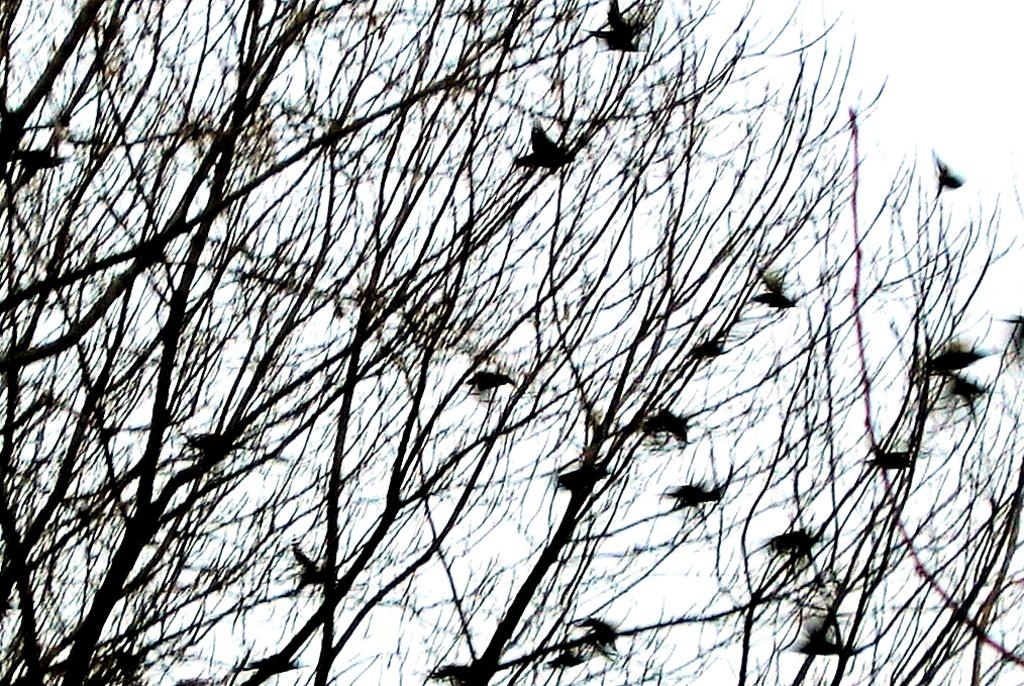What type of vegetation can be seen in the image? There are dried trees in the image. What animals are present in the image? There are birds in the image. What part of the natural environment is visible in the image? The sky is visible in the image. What type of cabbage is being used as a representative in the image? There is no cabbage present in the image, and no representative is mentioned. 